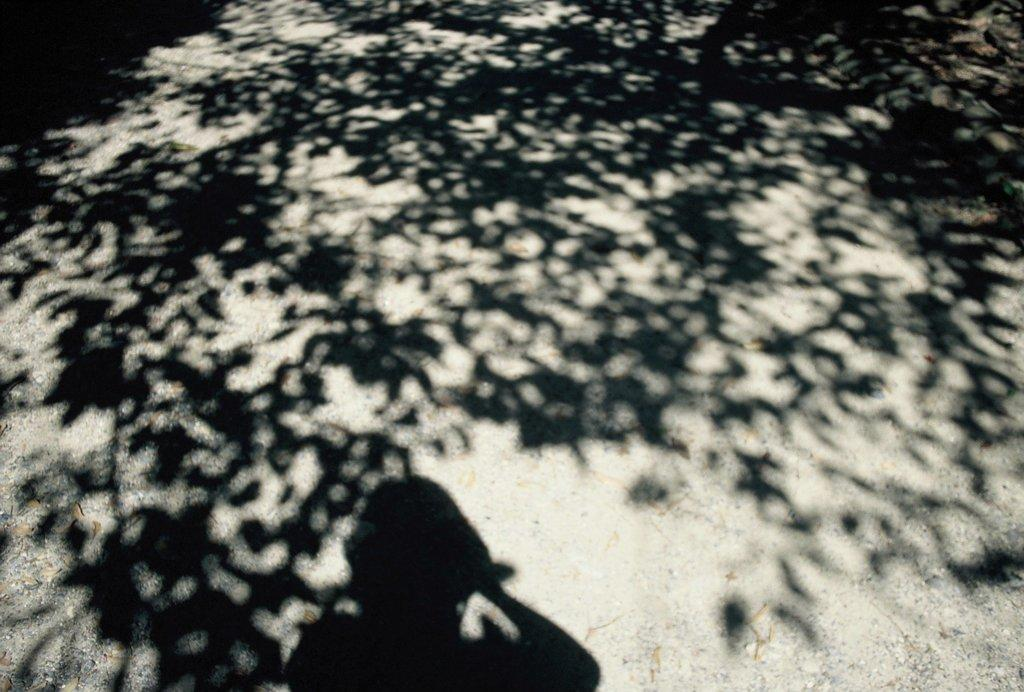What is the main feature of the image? There is a road in the image. What can be seen on the road? The shadow of a tree and the shadow of a woman are visible on the road. What type of nerve can be seen in the image? There is no nerve present in the image; it features a road with shadows of a tree and a woman. 